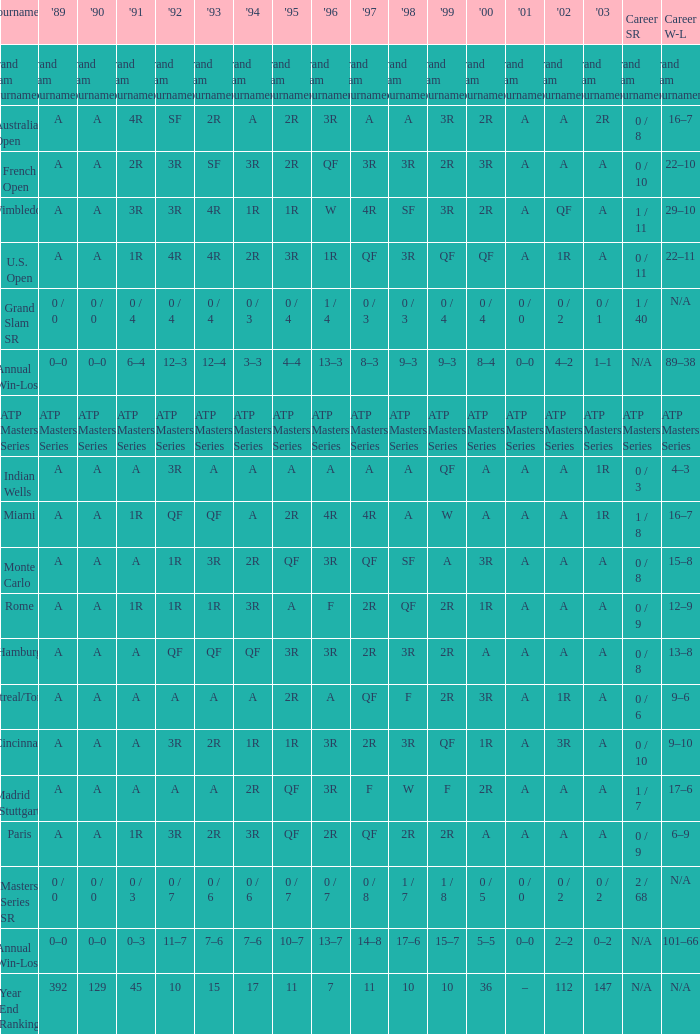What was the 1997 value when 2002 was A and 2003 was 1R? A, 4R. 